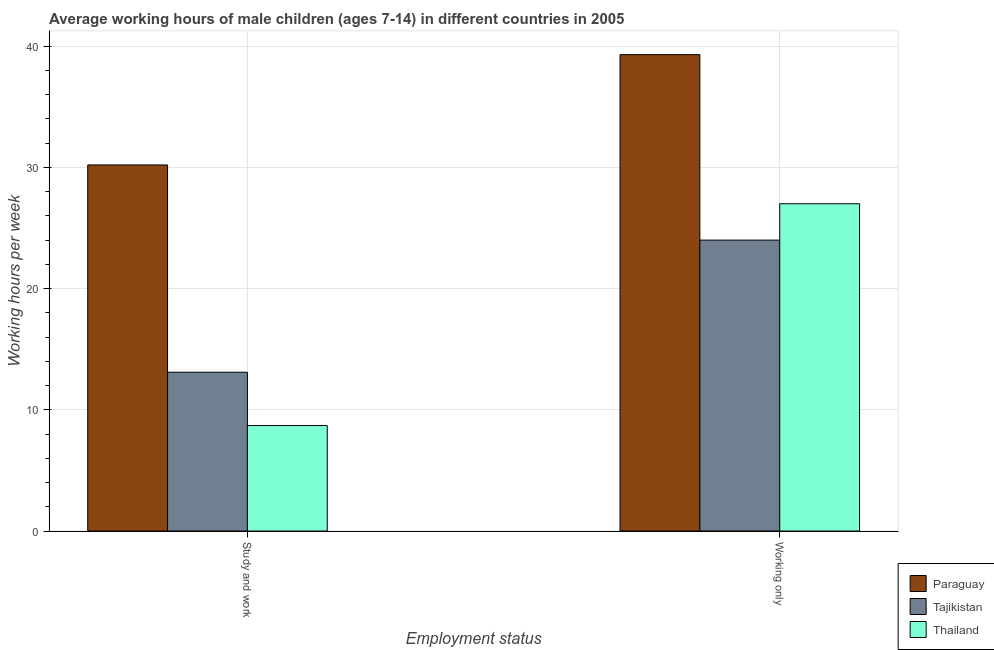How many groups of bars are there?
Offer a terse response. 2. Are the number of bars per tick equal to the number of legend labels?
Your response must be concise. Yes. How many bars are there on the 2nd tick from the left?
Your answer should be very brief. 3. What is the label of the 2nd group of bars from the left?
Offer a very short reply. Working only. Across all countries, what is the maximum average working hour of children involved in study and work?
Offer a terse response. 30.2. Across all countries, what is the minimum average working hour of children involved in study and work?
Ensure brevity in your answer.  8.7. In which country was the average working hour of children involved in study and work maximum?
Keep it short and to the point. Paraguay. In which country was the average working hour of children involved in only work minimum?
Offer a terse response. Tajikistan. What is the total average working hour of children involved in only work in the graph?
Provide a succinct answer. 90.3. What is the difference between the average working hour of children involved in only work in Paraguay and that in Tajikistan?
Your answer should be compact. 15.3. What is the difference between the average working hour of children involved in study and work in Paraguay and the average working hour of children involved in only work in Thailand?
Ensure brevity in your answer.  3.2. What is the average average working hour of children involved in study and work per country?
Your answer should be compact. 17.33. What is the difference between the average working hour of children involved in only work and average working hour of children involved in study and work in Paraguay?
Provide a succinct answer. 9.1. What is the ratio of the average working hour of children involved in study and work in Tajikistan to that in Paraguay?
Your answer should be compact. 0.43. Is the average working hour of children involved in only work in Thailand less than that in Paraguay?
Your response must be concise. Yes. What does the 3rd bar from the left in Study and work represents?
Offer a very short reply. Thailand. What does the 1st bar from the right in Working only represents?
Offer a terse response. Thailand. How many bars are there?
Keep it short and to the point. 6. Are all the bars in the graph horizontal?
Keep it short and to the point. No. What is the difference between two consecutive major ticks on the Y-axis?
Provide a short and direct response. 10. Are the values on the major ticks of Y-axis written in scientific E-notation?
Keep it short and to the point. No. Does the graph contain any zero values?
Provide a succinct answer. No. Where does the legend appear in the graph?
Ensure brevity in your answer.  Bottom right. How are the legend labels stacked?
Offer a very short reply. Vertical. What is the title of the graph?
Provide a succinct answer. Average working hours of male children (ages 7-14) in different countries in 2005. What is the label or title of the X-axis?
Ensure brevity in your answer.  Employment status. What is the label or title of the Y-axis?
Give a very brief answer. Working hours per week. What is the Working hours per week of Paraguay in Study and work?
Give a very brief answer. 30.2. What is the Working hours per week in Thailand in Study and work?
Ensure brevity in your answer.  8.7. What is the Working hours per week in Paraguay in Working only?
Provide a succinct answer. 39.3. What is the Working hours per week of Tajikistan in Working only?
Keep it short and to the point. 24. What is the Working hours per week in Thailand in Working only?
Your answer should be very brief. 27. Across all Employment status, what is the maximum Working hours per week of Paraguay?
Your response must be concise. 39.3. Across all Employment status, what is the maximum Working hours per week of Tajikistan?
Keep it short and to the point. 24. Across all Employment status, what is the maximum Working hours per week of Thailand?
Your answer should be very brief. 27. Across all Employment status, what is the minimum Working hours per week in Paraguay?
Your answer should be compact. 30.2. Across all Employment status, what is the minimum Working hours per week in Tajikistan?
Give a very brief answer. 13.1. Across all Employment status, what is the minimum Working hours per week in Thailand?
Your response must be concise. 8.7. What is the total Working hours per week in Paraguay in the graph?
Make the answer very short. 69.5. What is the total Working hours per week in Tajikistan in the graph?
Provide a short and direct response. 37.1. What is the total Working hours per week of Thailand in the graph?
Make the answer very short. 35.7. What is the difference between the Working hours per week in Paraguay in Study and work and that in Working only?
Provide a succinct answer. -9.1. What is the difference between the Working hours per week of Tajikistan in Study and work and that in Working only?
Offer a very short reply. -10.9. What is the difference between the Working hours per week in Thailand in Study and work and that in Working only?
Your answer should be very brief. -18.3. What is the difference between the Working hours per week in Paraguay in Study and work and the Working hours per week in Tajikistan in Working only?
Your answer should be very brief. 6.2. What is the difference between the Working hours per week of Tajikistan in Study and work and the Working hours per week of Thailand in Working only?
Your response must be concise. -13.9. What is the average Working hours per week in Paraguay per Employment status?
Your answer should be very brief. 34.75. What is the average Working hours per week of Tajikistan per Employment status?
Provide a short and direct response. 18.55. What is the average Working hours per week in Thailand per Employment status?
Make the answer very short. 17.85. What is the ratio of the Working hours per week in Paraguay in Study and work to that in Working only?
Provide a short and direct response. 0.77. What is the ratio of the Working hours per week in Tajikistan in Study and work to that in Working only?
Provide a succinct answer. 0.55. What is the ratio of the Working hours per week in Thailand in Study and work to that in Working only?
Your response must be concise. 0.32. What is the difference between the highest and the second highest Working hours per week of Paraguay?
Provide a succinct answer. 9.1. What is the difference between the highest and the second highest Working hours per week of Tajikistan?
Offer a very short reply. 10.9. What is the difference between the highest and the second highest Working hours per week in Thailand?
Your response must be concise. 18.3. What is the difference between the highest and the lowest Working hours per week in Paraguay?
Give a very brief answer. 9.1. What is the difference between the highest and the lowest Working hours per week in Tajikistan?
Keep it short and to the point. 10.9. What is the difference between the highest and the lowest Working hours per week of Thailand?
Give a very brief answer. 18.3. 